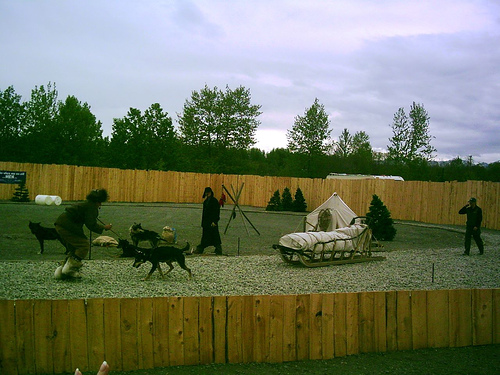What are the texture details of the small dog? While it's challenging to discern fine details due to the resolution and quality of the image, the texture of the small dog appears more on the untidy and messy side, characteristic of working dogs that might be regularly active outdoors. This analysis leads me to believe that option B, 'Untidy and messy,' is a more precise description than the provided answer of 'Rich and clear.' 